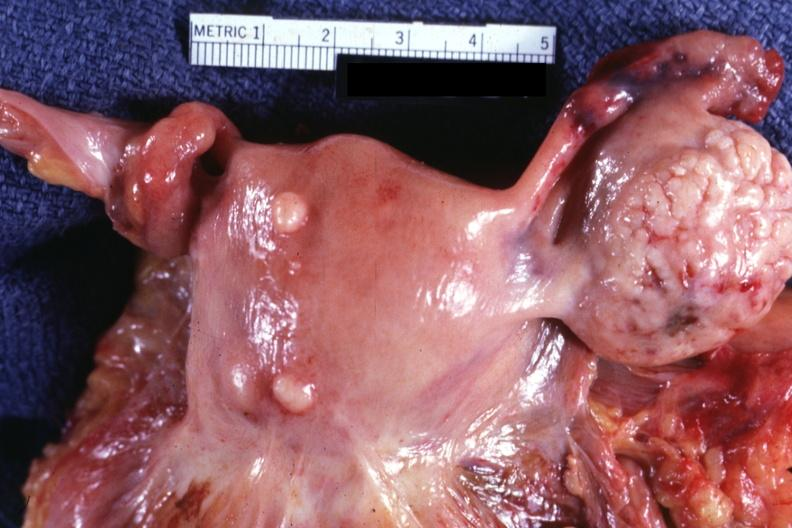does this image show external view of uterus with two small subserosal myomas?
Answer the question using a single word or phrase. Yes 